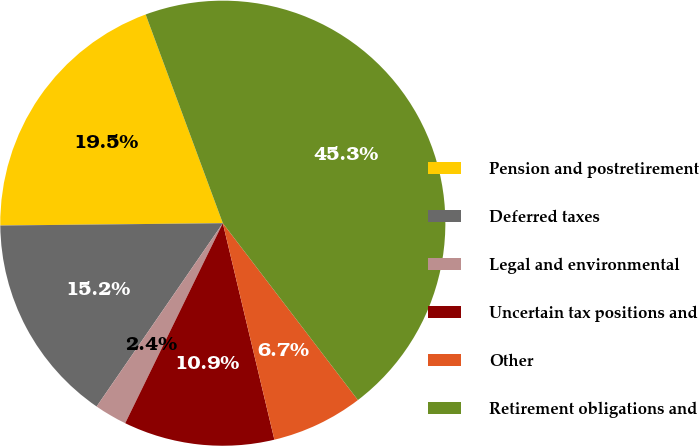<chart> <loc_0><loc_0><loc_500><loc_500><pie_chart><fcel>Pension and postretirement<fcel>Deferred taxes<fcel>Legal and environmental<fcel>Uncertain tax positions and<fcel>Other<fcel>Retirement obligations and<nl><fcel>19.53%<fcel>15.24%<fcel>2.37%<fcel>10.95%<fcel>6.66%<fcel>45.26%<nl></chart> 